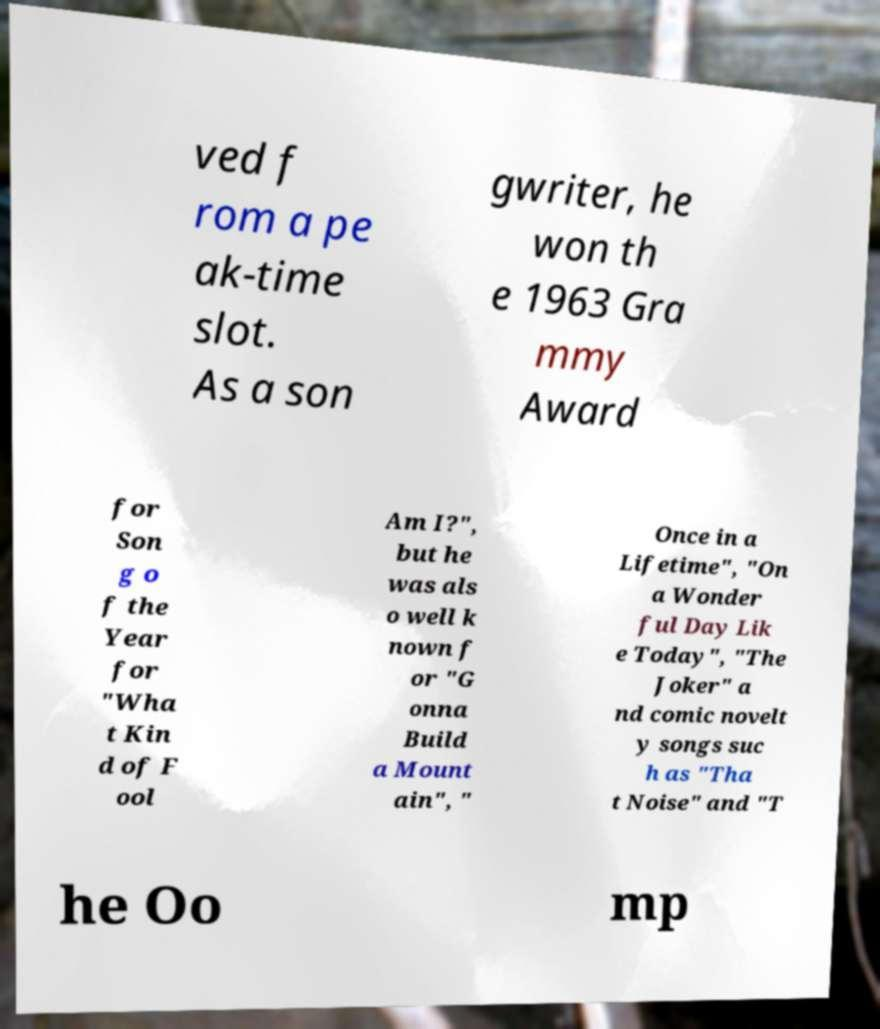For documentation purposes, I need the text within this image transcribed. Could you provide that? ved f rom a pe ak-time slot. As a son gwriter, he won th e 1963 Gra mmy Award for Son g o f the Year for "Wha t Kin d of F ool Am I?", but he was als o well k nown f or "G onna Build a Mount ain", " Once in a Lifetime", "On a Wonder ful Day Lik e Today", "The Joker" a nd comic novelt y songs suc h as "Tha t Noise" and "T he Oo mp 